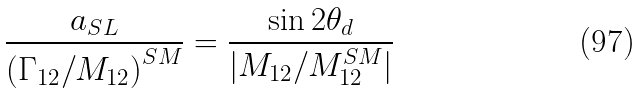Convert formula to latex. <formula><loc_0><loc_0><loc_500><loc_500>\frac { a _ { S L } } { { \left ( \Gamma _ { 1 2 } / M _ { 1 2 } \right ) } ^ { S M } } = \frac { \sin 2 \theta _ { d } } { | M _ { 1 2 } / M _ { 1 2 } ^ { S M } | }</formula> 